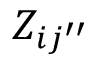Convert formula to latex. <formula><loc_0><loc_0><loc_500><loc_500>Z _ { i { j ^ { \prime \prime } } }</formula> 